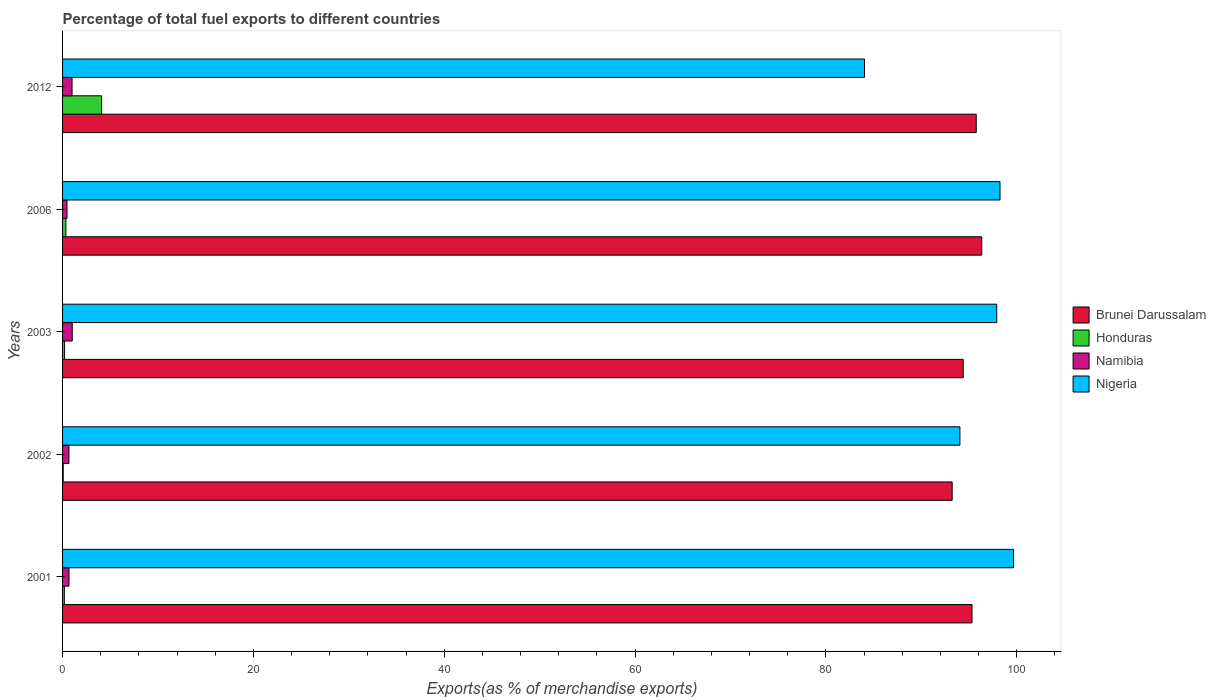How many different coloured bars are there?
Give a very brief answer. 4. How many groups of bars are there?
Your answer should be compact. 5. How many bars are there on the 2nd tick from the bottom?
Your answer should be very brief. 4. What is the label of the 1st group of bars from the top?
Keep it short and to the point. 2012. What is the percentage of exports to different countries in Brunei Darussalam in 2012?
Your answer should be compact. 95.75. Across all years, what is the maximum percentage of exports to different countries in Nigeria?
Ensure brevity in your answer.  99.66. Across all years, what is the minimum percentage of exports to different countries in Brunei Darussalam?
Ensure brevity in your answer.  93.23. In which year was the percentage of exports to different countries in Nigeria maximum?
Ensure brevity in your answer.  2001. In which year was the percentage of exports to different countries in Nigeria minimum?
Your answer should be very brief. 2012. What is the total percentage of exports to different countries in Namibia in the graph?
Make the answer very short. 3.81. What is the difference between the percentage of exports to different countries in Brunei Darussalam in 2001 and that in 2003?
Your answer should be compact. 0.92. What is the difference between the percentage of exports to different countries in Brunei Darussalam in 2006 and the percentage of exports to different countries in Honduras in 2003?
Offer a very short reply. 96.12. What is the average percentage of exports to different countries in Brunei Darussalam per year?
Keep it short and to the point. 95. In the year 2002, what is the difference between the percentage of exports to different countries in Honduras and percentage of exports to different countries in Namibia?
Ensure brevity in your answer.  -0.6. In how many years, is the percentage of exports to different countries in Honduras greater than 80 %?
Provide a short and direct response. 0. What is the ratio of the percentage of exports to different countries in Nigeria in 2002 to that in 2003?
Provide a succinct answer. 0.96. Is the percentage of exports to different countries in Nigeria in 2001 less than that in 2002?
Ensure brevity in your answer.  No. What is the difference between the highest and the second highest percentage of exports to different countries in Namibia?
Keep it short and to the point. 0.02. What is the difference between the highest and the lowest percentage of exports to different countries in Nigeria?
Your answer should be compact. 15.62. Is it the case that in every year, the sum of the percentage of exports to different countries in Nigeria and percentage of exports to different countries in Namibia is greater than the sum of percentage of exports to different countries in Honduras and percentage of exports to different countries in Brunei Darussalam?
Keep it short and to the point. Yes. What does the 2nd bar from the top in 2001 represents?
Your answer should be compact. Namibia. What does the 1st bar from the bottom in 2003 represents?
Offer a terse response. Brunei Darussalam. Is it the case that in every year, the sum of the percentage of exports to different countries in Brunei Darussalam and percentage of exports to different countries in Namibia is greater than the percentage of exports to different countries in Honduras?
Offer a terse response. Yes. What is the difference between two consecutive major ticks on the X-axis?
Your answer should be compact. 20. Does the graph contain any zero values?
Give a very brief answer. No. Does the graph contain grids?
Your response must be concise. No. Where does the legend appear in the graph?
Provide a short and direct response. Center right. How are the legend labels stacked?
Make the answer very short. Vertical. What is the title of the graph?
Provide a short and direct response. Percentage of total fuel exports to different countries. Does "Zambia" appear as one of the legend labels in the graph?
Your answer should be compact. No. What is the label or title of the X-axis?
Give a very brief answer. Exports(as % of merchandise exports). What is the label or title of the Y-axis?
Offer a very short reply. Years. What is the Exports(as % of merchandise exports) of Brunei Darussalam in 2001?
Offer a very short reply. 95.31. What is the Exports(as % of merchandise exports) of Honduras in 2001?
Offer a very short reply. 0.18. What is the Exports(as % of merchandise exports) in Namibia in 2001?
Your answer should be compact. 0.67. What is the Exports(as % of merchandise exports) in Nigeria in 2001?
Your answer should be very brief. 99.66. What is the Exports(as % of merchandise exports) in Brunei Darussalam in 2002?
Keep it short and to the point. 93.23. What is the Exports(as % of merchandise exports) in Honduras in 2002?
Offer a very short reply. 0.07. What is the Exports(as % of merchandise exports) of Namibia in 2002?
Provide a succinct answer. 0.67. What is the Exports(as % of merchandise exports) in Nigeria in 2002?
Make the answer very short. 94.04. What is the Exports(as % of merchandise exports) in Brunei Darussalam in 2003?
Keep it short and to the point. 94.38. What is the Exports(as % of merchandise exports) of Honduras in 2003?
Your answer should be very brief. 0.21. What is the Exports(as % of merchandise exports) in Namibia in 2003?
Provide a succinct answer. 1.01. What is the Exports(as % of merchandise exports) of Nigeria in 2003?
Ensure brevity in your answer.  97.9. What is the Exports(as % of merchandise exports) of Brunei Darussalam in 2006?
Provide a short and direct response. 96.33. What is the Exports(as % of merchandise exports) in Honduras in 2006?
Keep it short and to the point. 0.35. What is the Exports(as % of merchandise exports) of Namibia in 2006?
Make the answer very short. 0.47. What is the Exports(as % of merchandise exports) of Nigeria in 2006?
Your response must be concise. 98.24. What is the Exports(as % of merchandise exports) of Brunei Darussalam in 2012?
Keep it short and to the point. 95.75. What is the Exports(as % of merchandise exports) of Honduras in 2012?
Offer a terse response. 4.09. What is the Exports(as % of merchandise exports) in Namibia in 2012?
Your answer should be compact. 0.99. What is the Exports(as % of merchandise exports) of Nigeria in 2012?
Offer a terse response. 84.04. Across all years, what is the maximum Exports(as % of merchandise exports) of Brunei Darussalam?
Ensure brevity in your answer.  96.33. Across all years, what is the maximum Exports(as % of merchandise exports) of Honduras?
Provide a succinct answer. 4.09. Across all years, what is the maximum Exports(as % of merchandise exports) in Namibia?
Your answer should be very brief. 1.01. Across all years, what is the maximum Exports(as % of merchandise exports) of Nigeria?
Make the answer very short. 99.66. Across all years, what is the minimum Exports(as % of merchandise exports) of Brunei Darussalam?
Your response must be concise. 93.23. Across all years, what is the minimum Exports(as % of merchandise exports) of Honduras?
Your response must be concise. 0.07. Across all years, what is the minimum Exports(as % of merchandise exports) of Namibia?
Provide a succinct answer. 0.47. Across all years, what is the minimum Exports(as % of merchandise exports) in Nigeria?
Provide a succinct answer. 84.04. What is the total Exports(as % of merchandise exports) in Brunei Darussalam in the graph?
Offer a very short reply. 474.99. What is the total Exports(as % of merchandise exports) in Honduras in the graph?
Your answer should be compact. 4.9. What is the total Exports(as % of merchandise exports) in Namibia in the graph?
Offer a very short reply. 3.81. What is the total Exports(as % of merchandise exports) in Nigeria in the graph?
Offer a very short reply. 473.87. What is the difference between the Exports(as % of merchandise exports) in Brunei Darussalam in 2001 and that in 2002?
Ensure brevity in your answer.  2.08. What is the difference between the Exports(as % of merchandise exports) in Honduras in 2001 and that in 2002?
Keep it short and to the point. 0.12. What is the difference between the Exports(as % of merchandise exports) of Namibia in 2001 and that in 2002?
Your answer should be compact. 0.01. What is the difference between the Exports(as % of merchandise exports) of Nigeria in 2001 and that in 2002?
Ensure brevity in your answer.  5.62. What is the difference between the Exports(as % of merchandise exports) in Brunei Darussalam in 2001 and that in 2003?
Provide a short and direct response. 0.92. What is the difference between the Exports(as % of merchandise exports) in Honduras in 2001 and that in 2003?
Keep it short and to the point. -0.03. What is the difference between the Exports(as % of merchandise exports) of Namibia in 2001 and that in 2003?
Your answer should be compact. -0.34. What is the difference between the Exports(as % of merchandise exports) in Nigeria in 2001 and that in 2003?
Give a very brief answer. 1.76. What is the difference between the Exports(as % of merchandise exports) of Brunei Darussalam in 2001 and that in 2006?
Your answer should be very brief. -1.02. What is the difference between the Exports(as % of merchandise exports) of Honduras in 2001 and that in 2006?
Provide a short and direct response. -0.17. What is the difference between the Exports(as % of merchandise exports) of Namibia in 2001 and that in 2006?
Provide a succinct answer. 0.21. What is the difference between the Exports(as % of merchandise exports) of Nigeria in 2001 and that in 2006?
Offer a very short reply. 1.42. What is the difference between the Exports(as % of merchandise exports) of Brunei Darussalam in 2001 and that in 2012?
Your answer should be very brief. -0.44. What is the difference between the Exports(as % of merchandise exports) of Honduras in 2001 and that in 2012?
Give a very brief answer. -3.91. What is the difference between the Exports(as % of merchandise exports) of Namibia in 2001 and that in 2012?
Provide a short and direct response. -0.32. What is the difference between the Exports(as % of merchandise exports) of Nigeria in 2001 and that in 2012?
Offer a very short reply. 15.62. What is the difference between the Exports(as % of merchandise exports) of Brunei Darussalam in 2002 and that in 2003?
Keep it short and to the point. -1.16. What is the difference between the Exports(as % of merchandise exports) of Honduras in 2002 and that in 2003?
Give a very brief answer. -0.14. What is the difference between the Exports(as % of merchandise exports) of Namibia in 2002 and that in 2003?
Provide a short and direct response. -0.35. What is the difference between the Exports(as % of merchandise exports) in Nigeria in 2002 and that in 2003?
Keep it short and to the point. -3.86. What is the difference between the Exports(as % of merchandise exports) in Brunei Darussalam in 2002 and that in 2006?
Give a very brief answer. -3.1. What is the difference between the Exports(as % of merchandise exports) in Honduras in 2002 and that in 2006?
Provide a succinct answer. -0.28. What is the difference between the Exports(as % of merchandise exports) of Namibia in 2002 and that in 2006?
Your response must be concise. 0.2. What is the difference between the Exports(as % of merchandise exports) in Nigeria in 2002 and that in 2006?
Your answer should be compact. -4.2. What is the difference between the Exports(as % of merchandise exports) in Brunei Darussalam in 2002 and that in 2012?
Provide a succinct answer. -2.52. What is the difference between the Exports(as % of merchandise exports) in Honduras in 2002 and that in 2012?
Your answer should be compact. -4.02. What is the difference between the Exports(as % of merchandise exports) in Namibia in 2002 and that in 2012?
Provide a short and direct response. -0.33. What is the difference between the Exports(as % of merchandise exports) of Nigeria in 2002 and that in 2012?
Your answer should be very brief. 10. What is the difference between the Exports(as % of merchandise exports) in Brunei Darussalam in 2003 and that in 2006?
Your answer should be very brief. -1.94. What is the difference between the Exports(as % of merchandise exports) of Honduras in 2003 and that in 2006?
Keep it short and to the point. -0.14. What is the difference between the Exports(as % of merchandise exports) of Namibia in 2003 and that in 2006?
Keep it short and to the point. 0.55. What is the difference between the Exports(as % of merchandise exports) of Nigeria in 2003 and that in 2006?
Offer a very short reply. -0.34. What is the difference between the Exports(as % of merchandise exports) in Brunei Darussalam in 2003 and that in 2012?
Provide a short and direct response. -1.37. What is the difference between the Exports(as % of merchandise exports) of Honduras in 2003 and that in 2012?
Provide a succinct answer. -3.88. What is the difference between the Exports(as % of merchandise exports) in Namibia in 2003 and that in 2012?
Keep it short and to the point. 0.02. What is the difference between the Exports(as % of merchandise exports) in Nigeria in 2003 and that in 2012?
Your response must be concise. 13.86. What is the difference between the Exports(as % of merchandise exports) of Brunei Darussalam in 2006 and that in 2012?
Make the answer very short. 0.58. What is the difference between the Exports(as % of merchandise exports) of Honduras in 2006 and that in 2012?
Make the answer very short. -3.74. What is the difference between the Exports(as % of merchandise exports) in Namibia in 2006 and that in 2012?
Give a very brief answer. -0.53. What is the difference between the Exports(as % of merchandise exports) of Nigeria in 2006 and that in 2012?
Keep it short and to the point. 14.2. What is the difference between the Exports(as % of merchandise exports) of Brunei Darussalam in 2001 and the Exports(as % of merchandise exports) of Honduras in 2002?
Offer a terse response. 95.24. What is the difference between the Exports(as % of merchandise exports) of Brunei Darussalam in 2001 and the Exports(as % of merchandise exports) of Namibia in 2002?
Your answer should be compact. 94.64. What is the difference between the Exports(as % of merchandise exports) in Brunei Darussalam in 2001 and the Exports(as % of merchandise exports) in Nigeria in 2002?
Offer a very short reply. 1.27. What is the difference between the Exports(as % of merchandise exports) of Honduras in 2001 and the Exports(as % of merchandise exports) of Namibia in 2002?
Provide a succinct answer. -0.48. What is the difference between the Exports(as % of merchandise exports) of Honduras in 2001 and the Exports(as % of merchandise exports) of Nigeria in 2002?
Your answer should be compact. -93.85. What is the difference between the Exports(as % of merchandise exports) of Namibia in 2001 and the Exports(as % of merchandise exports) of Nigeria in 2002?
Give a very brief answer. -93.36. What is the difference between the Exports(as % of merchandise exports) in Brunei Darussalam in 2001 and the Exports(as % of merchandise exports) in Honduras in 2003?
Offer a terse response. 95.1. What is the difference between the Exports(as % of merchandise exports) in Brunei Darussalam in 2001 and the Exports(as % of merchandise exports) in Namibia in 2003?
Ensure brevity in your answer.  94.29. What is the difference between the Exports(as % of merchandise exports) in Brunei Darussalam in 2001 and the Exports(as % of merchandise exports) in Nigeria in 2003?
Provide a short and direct response. -2.59. What is the difference between the Exports(as % of merchandise exports) of Honduras in 2001 and the Exports(as % of merchandise exports) of Namibia in 2003?
Ensure brevity in your answer.  -0.83. What is the difference between the Exports(as % of merchandise exports) of Honduras in 2001 and the Exports(as % of merchandise exports) of Nigeria in 2003?
Ensure brevity in your answer.  -97.71. What is the difference between the Exports(as % of merchandise exports) in Namibia in 2001 and the Exports(as % of merchandise exports) in Nigeria in 2003?
Make the answer very short. -97.22. What is the difference between the Exports(as % of merchandise exports) in Brunei Darussalam in 2001 and the Exports(as % of merchandise exports) in Honduras in 2006?
Your response must be concise. 94.96. What is the difference between the Exports(as % of merchandise exports) in Brunei Darussalam in 2001 and the Exports(as % of merchandise exports) in Namibia in 2006?
Your answer should be compact. 94.84. What is the difference between the Exports(as % of merchandise exports) of Brunei Darussalam in 2001 and the Exports(as % of merchandise exports) of Nigeria in 2006?
Your response must be concise. -2.93. What is the difference between the Exports(as % of merchandise exports) in Honduras in 2001 and the Exports(as % of merchandise exports) in Namibia in 2006?
Your response must be concise. -0.28. What is the difference between the Exports(as % of merchandise exports) of Honduras in 2001 and the Exports(as % of merchandise exports) of Nigeria in 2006?
Your answer should be compact. -98.05. What is the difference between the Exports(as % of merchandise exports) in Namibia in 2001 and the Exports(as % of merchandise exports) in Nigeria in 2006?
Provide a succinct answer. -97.56. What is the difference between the Exports(as % of merchandise exports) of Brunei Darussalam in 2001 and the Exports(as % of merchandise exports) of Honduras in 2012?
Provide a short and direct response. 91.22. What is the difference between the Exports(as % of merchandise exports) of Brunei Darussalam in 2001 and the Exports(as % of merchandise exports) of Namibia in 2012?
Offer a very short reply. 94.31. What is the difference between the Exports(as % of merchandise exports) of Brunei Darussalam in 2001 and the Exports(as % of merchandise exports) of Nigeria in 2012?
Ensure brevity in your answer.  11.27. What is the difference between the Exports(as % of merchandise exports) in Honduras in 2001 and the Exports(as % of merchandise exports) in Namibia in 2012?
Your response must be concise. -0.81. What is the difference between the Exports(as % of merchandise exports) in Honduras in 2001 and the Exports(as % of merchandise exports) in Nigeria in 2012?
Your answer should be compact. -83.85. What is the difference between the Exports(as % of merchandise exports) in Namibia in 2001 and the Exports(as % of merchandise exports) in Nigeria in 2012?
Provide a short and direct response. -83.36. What is the difference between the Exports(as % of merchandise exports) of Brunei Darussalam in 2002 and the Exports(as % of merchandise exports) of Honduras in 2003?
Your answer should be compact. 93.02. What is the difference between the Exports(as % of merchandise exports) in Brunei Darussalam in 2002 and the Exports(as % of merchandise exports) in Namibia in 2003?
Ensure brevity in your answer.  92.21. What is the difference between the Exports(as % of merchandise exports) of Brunei Darussalam in 2002 and the Exports(as % of merchandise exports) of Nigeria in 2003?
Offer a terse response. -4.67. What is the difference between the Exports(as % of merchandise exports) of Honduras in 2002 and the Exports(as % of merchandise exports) of Namibia in 2003?
Ensure brevity in your answer.  -0.95. What is the difference between the Exports(as % of merchandise exports) of Honduras in 2002 and the Exports(as % of merchandise exports) of Nigeria in 2003?
Offer a very short reply. -97.83. What is the difference between the Exports(as % of merchandise exports) of Namibia in 2002 and the Exports(as % of merchandise exports) of Nigeria in 2003?
Ensure brevity in your answer.  -97.23. What is the difference between the Exports(as % of merchandise exports) in Brunei Darussalam in 2002 and the Exports(as % of merchandise exports) in Honduras in 2006?
Your answer should be very brief. 92.88. What is the difference between the Exports(as % of merchandise exports) in Brunei Darussalam in 2002 and the Exports(as % of merchandise exports) in Namibia in 2006?
Offer a terse response. 92.76. What is the difference between the Exports(as % of merchandise exports) of Brunei Darussalam in 2002 and the Exports(as % of merchandise exports) of Nigeria in 2006?
Provide a short and direct response. -5.01. What is the difference between the Exports(as % of merchandise exports) in Honduras in 2002 and the Exports(as % of merchandise exports) in Namibia in 2006?
Your answer should be very brief. -0.4. What is the difference between the Exports(as % of merchandise exports) of Honduras in 2002 and the Exports(as % of merchandise exports) of Nigeria in 2006?
Your response must be concise. -98.17. What is the difference between the Exports(as % of merchandise exports) in Namibia in 2002 and the Exports(as % of merchandise exports) in Nigeria in 2006?
Make the answer very short. -97.57. What is the difference between the Exports(as % of merchandise exports) of Brunei Darussalam in 2002 and the Exports(as % of merchandise exports) of Honduras in 2012?
Your response must be concise. 89.14. What is the difference between the Exports(as % of merchandise exports) in Brunei Darussalam in 2002 and the Exports(as % of merchandise exports) in Namibia in 2012?
Give a very brief answer. 92.23. What is the difference between the Exports(as % of merchandise exports) in Brunei Darussalam in 2002 and the Exports(as % of merchandise exports) in Nigeria in 2012?
Give a very brief answer. 9.19. What is the difference between the Exports(as % of merchandise exports) in Honduras in 2002 and the Exports(as % of merchandise exports) in Namibia in 2012?
Offer a terse response. -0.93. What is the difference between the Exports(as % of merchandise exports) of Honduras in 2002 and the Exports(as % of merchandise exports) of Nigeria in 2012?
Keep it short and to the point. -83.97. What is the difference between the Exports(as % of merchandise exports) in Namibia in 2002 and the Exports(as % of merchandise exports) in Nigeria in 2012?
Offer a very short reply. -83.37. What is the difference between the Exports(as % of merchandise exports) of Brunei Darussalam in 2003 and the Exports(as % of merchandise exports) of Honduras in 2006?
Your response must be concise. 94.03. What is the difference between the Exports(as % of merchandise exports) of Brunei Darussalam in 2003 and the Exports(as % of merchandise exports) of Namibia in 2006?
Your answer should be compact. 93.92. What is the difference between the Exports(as % of merchandise exports) in Brunei Darussalam in 2003 and the Exports(as % of merchandise exports) in Nigeria in 2006?
Keep it short and to the point. -3.86. What is the difference between the Exports(as % of merchandise exports) of Honduras in 2003 and the Exports(as % of merchandise exports) of Namibia in 2006?
Offer a very short reply. -0.26. What is the difference between the Exports(as % of merchandise exports) of Honduras in 2003 and the Exports(as % of merchandise exports) of Nigeria in 2006?
Make the answer very short. -98.03. What is the difference between the Exports(as % of merchandise exports) of Namibia in 2003 and the Exports(as % of merchandise exports) of Nigeria in 2006?
Make the answer very short. -97.23. What is the difference between the Exports(as % of merchandise exports) in Brunei Darussalam in 2003 and the Exports(as % of merchandise exports) in Honduras in 2012?
Your answer should be very brief. 90.29. What is the difference between the Exports(as % of merchandise exports) in Brunei Darussalam in 2003 and the Exports(as % of merchandise exports) in Namibia in 2012?
Keep it short and to the point. 93.39. What is the difference between the Exports(as % of merchandise exports) of Brunei Darussalam in 2003 and the Exports(as % of merchandise exports) of Nigeria in 2012?
Provide a short and direct response. 10.34. What is the difference between the Exports(as % of merchandise exports) of Honduras in 2003 and the Exports(as % of merchandise exports) of Namibia in 2012?
Make the answer very short. -0.78. What is the difference between the Exports(as % of merchandise exports) of Honduras in 2003 and the Exports(as % of merchandise exports) of Nigeria in 2012?
Provide a short and direct response. -83.83. What is the difference between the Exports(as % of merchandise exports) in Namibia in 2003 and the Exports(as % of merchandise exports) in Nigeria in 2012?
Your response must be concise. -83.03. What is the difference between the Exports(as % of merchandise exports) in Brunei Darussalam in 2006 and the Exports(as % of merchandise exports) in Honduras in 2012?
Your response must be concise. 92.24. What is the difference between the Exports(as % of merchandise exports) of Brunei Darussalam in 2006 and the Exports(as % of merchandise exports) of Namibia in 2012?
Ensure brevity in your answer.  95.33. What is the difference between the Exports(as % of merchandise exports) in Brunei Darussalam in 2006 and the Exports(as % of merchandise exports) in Nigeria in 2012?
Offer a terse response. 12.29. What is the difference between the Exports(as % of merchandise exports) in Honduras in 2006 and the Exports(as % of merchandise exports) in Namibia in 2012?
Make the answer very short. -0.64. What is the difference between the Exports(as % of merchandise exports) in Honduras in 2006 and the Exports(as % of merchandise exports) in Nigeria in 2012?
Ensure brevity in your answer.  -83.69. What is the difference between the Exports(as % of merchandise exports) of Namibia in 2006 and the Exports(as % of merchandise exports) of Nigeria in 2012?
Give a very brief answer. -83.57. What is the average Exports(as % of merchandise exports) of Brunei Darussalam per year?
Offer a very short reply. 95. What is the average Exports(as % of merchandise exports) of Honduras per year?
Offer a very short reply. 0.98. What is the average Exports(as % of merchandise exports) in Namibia per year?
Provide a short and direct response. 0.76. What is the average Exports(as % of merchandise exports) in Nigeria per year?
Offer a very short reply. 94.77. In the year 2001, what is the difference between the Exports(as % of merchandise exports) of Brunei Darussalam and Exports(as % of merchandise exports) of Honduras?
Keep it short and to the point. 95.12. In the year 2001, what is the difference between the Exports(as % of merchandise exports) of Brunei Darussalam and Exports(as % of merchandise exports) of Namibia?
Offer a terse response. 94.63. In the year 2001, what is the difference between the Exports(as % of merchandise exports) in Brunei Darussalam and Exports(as % of merchandise exports) in Nigeria?
Offer a very short reply. -4.35. In the year 2001, what is the difference between the Exports(as % of merchandise exports) in Honduras and Exports(as % of merchandise exports) in Namibia?
Offer a terse response. -0.49. In the year 2001, what is the difference between the Exports(as % of merchandise exports) in Honduras and Exports(as % of merchandise exports) in Nigeria?
Your answer should be compact. -99.47. In the year 2001, what is the difference between the Exports(as % of merchandise exports) in Namibia and Exports(as % of merchandise exports) in Nigeria?
Offer a terse response. -98.98. In the year 2002, what is the difference between the Exports(as % of merchandise exports) of Brunei Darussalam and Exports(as % of merchandise exports) of Honduras?
Provide a succinct answer. 93.16. In the year 2002, what is the difference between the Exports(as % of merchandise exports) in Brunei Darussalam and Exports(as % of merchandise exports) in Namibia?
Make the answer very short. 92.56. In the year 2002, what is the difference between the Exports(as % of merchandise exports) in Brunei Darussalam and Exports(as % of merchandise exports) in Nigeria?
Your response must be concise. -0.81. In the year 2002, what is the difference between the Exports(as % of merchandise exports) of Honduras and Exports(as % of merchandise exports) of Namibia?
Give a very brief answer. -0.6. In the year 2002, what is the difference between the Exports(as % of merchandise exports) in Honduras and Exports(as % of merchandise exports) in Nigeria?
Offer a terse response. -93.97. In the year 2002, what is the difference between the Exports(as % of merchandise exports) in Namibia and Exports(as % of merchandise exports) in Nigeria?
Provide a short and direct response. -93.37. In the year 2003, what is the difference between the Exports(as % of merchandise exports) in Brunei Darussalam and Exports(as % of merchandise exports) in Honduras?
Give a very brief answer. 94.17. In the year 2003, what is the difference between the Exports(as % of merchandise exports) of Brunei Darussalam and Exports(as % of merchandise exports) of Namibia?
Your response must be concise. 93.37. In the year 2003, what is the difference between the Exports(as % of merchandise exports) in Brunei Darussalam and Exports(as % of merchandise exports) in Nigeria?
Keep it short and to the point. -3.52. In the year 2003, what is the difference between the Exports(as % of merchandise exports) of Honduras and Exports(as % of merchandise exports) of Namibia?
Ensure brevity in your answer.  -0.8. In the year 2003, what is the difference between the Exports(as % of merchandise exports) in Honduras and Exports(as % of merchandise exports) in Nigeria?
Give a very brief answer. -97.69. In the year 2003, what is the difference between the Exports(as % of merchandise exports) of Namibia and Exports(as % of merchandise exports) of Nigeria?
Ensure brevity in your answer.  -96.88. In the year 2006, what is the difference between the Exports(as % of merchandise exports) of Brunei Darussalam and Exports(as % of merchandise exports) of Honduras?
Ensure brevity in your answer.  95.98. In the year 2006, what is the difference between the Exports(as % of merchandise exports) of Brunei Darussalam and Exports(as % of merchandise exports) of Namibia?
Offer a terse response. 95.86. In the year 2006, what is the difference between the Exports(as % of merchandise exports) in Brunei Darussalam and Exports(as % of merchandise exports) in Nigeria?
Your answer should be very brief. -1.91. In the year 2006, what is the difference between the Exports(as % of merchandise exports) of Honduras and Exports(as % of merchandise exports) of Namibia?
Keep it short and to the point. -0.11. In the year 2006, what is the difference between the Exports(as % of merchandise exports) of Honduras and Exports(as % of merchandise exports) of Nigeria?
Your response must be concise. -97.89. In the year 2006, what is the difference between the Exports(as % of merchandise exports) in Namibia and Exports(as % of merchandise exports) in Nigeria?
Give a very brief answer. -97.77. In the year 2012, what is the difference between the Exports(as % of merchandise exports) of Brunei Darussalam and Exports(as % of merchandise exports) of Honduras?
Offer a terse response. 91.66. In the year 2012, what is the difference between the Exports(as % of merchandise exports) of Brunei Darussalam and Exports(as % of merchandise exports) of Namibia?
Your answer should be very brief. 94.76. In the year 2012, what is the difference between the Exports(as % of merchandise exports) in Brunei Darussalam and Exports(as % of merchandise exports) in Nigeria?
Keep it short and to the point. 11.71. In the year 2012, what is the difference between the Exports(as % of merchandise exports) in Honduras and Exports(as % of merchandise exports) in Namibia?
Make the answer very short. 3.1. In the year 2012, what is the difference between the Exports(as % of merchandise exports) in Honduras and Exports(as % of merchandise exports) in Nigeria?
Ensure brevity in your answer.  -79.95. In the year 2012, what is the difference between the Exports(as % of merchandise exports) of Namibia and Exports(as % of merchandise exports) of Nigeria?
Your response must be concise. -83.05. What is the ratio of the Exports(as % of merchandise exports) of Brunei Darussalam in 2001 to that in 2002?
Make the answer very short. 1.02. What is the ratio of the Exports(as % of merchandise exports) of Honduras in 2001 to that in 2002?
Offer a terse response. 2.77. What is the ratio of the Exports(as % of merchandise exports) of Namibia in 2001 to that in 2002?
Offer a very short reply. 1.01. What is the ratio of the Exports(as % of merchandise exports) in Nigeria in 2001 to that in 2002?
Your answer should be compact. 1.06. What is the ratio of the Exports(as % of merchandise exports) of Brunei Darussalam in 2001 to that in 2003?
Keep it short and to the point. 1.01. What is the ratio of the Exports(as % of merchandise exports) in Honduras in 2001 to that in 2003?
Offer a very short reply. 0.88. What is the ratio of the Exports(as % of merchandise exports) in Namibia in 2001 to that in 2003?
Offer a terse response. 0.67. What is the ratio of the Exports(as % of merchandise exports) in Nigeria in 2001 to that in 2003?
Provide a short and direct response. 1.02. What is the ratio of the Exports(as % of merchandise exports) of Brunei Darussalam in 2001 to that in 2006?
Ensure brevity in your answer.  0.99. What is the ratio of the Exports(as % of merchandise exports) of Honduras in 2001 to that in 2006?
Offer a terse response. 0.53. What is the ratio of the Exports(as % of merchandise exports) in Namibia in 2001 to that in 2006?
Your answer should be compact. 1.45. What is the ratio of the Exports(as % of merchandise exports) in Nigeria in 2001 to that in 2006?
Provide a succinct answer. 1.01. What is the ratio of the Exports(as % of merchandise exports) of Brunei Darussalam in 2001 to that in 2012?
Offer a terse response. 1. What is the ratio of the Exports(as % of merchandise exports) of Honduras in 2001 to that in 2012?
Give a very brief answer. 0.05. What is the ratio of the Exports(as % of merchandise exports) of Namibia in 2001 to that in 2012?
Give a very brief answer. 0.68. What is the ratio of the Exports(as % of merchandise exports) in Nigeria in 2001 to that in 2012?
Your response must be concise. 1.19. What is the ratio of the Exports(as % of merchandise exports) in Brunei Darussalam in 2002 to that in 2003?
Offer a very short reply. 0.99. What is the ratio of the Exports(as % of merchandise exports) in Honduras in 2002 to that in 2003?
Provide a short and direct response. 0.32. What is the ratio of the Exports(as % of merchandise exports) of Namibia in 2002 to that in 2003?
Provide a short and direct response. 0.66. What is the ratio of the Exports(as % of merchandise exports) of Nigeria in 2002 to that in 2003?
Keep it short and to the point. 0.96. What is the ratio of the Exports(as % of merchandise exports) in Brunei Darussalam in 2002 to that in 2006?
Keep it short and to the point. 0.97. What is the ratio of the Exports(as % of merchandise exports) of Honduras in 2002 to that in 2006?
Provide a succinct answer. 0.19. What is the ratio of the Exports(as % of merchandise exports) in Namibia in 2002 to that in 2006?
Your response must be concise. 1.43. What is the ratio of the Exports(as % of merchandise exports) of Nigeria in 2002 to that in 2006?
Offer a terse response. 0.96. What is the ratio of the Exports(as % of merchandise exports) in Brunei Darussalam in 2002 to that in 2012?
Offer a very short reply. 0.97. What is the ratio of the Exports(as % of merchandise exports) in Honduras in 2002 to that in 2012?
Your answer should be very brief. 0.02. What is the ratio of the Exports(as % of merchandise exports) of Namibia in 2002 to that in 2012?
Offer a very short reply. 0.67. What is the ratio of the Exports(as % of merchandise exports) in Nigeria in 2002 to that in 2012?
Keep it short and to the point. 1.12. What is the ratio of the Exports(as % of merchandise exports) of Brunei Darussalam in 2003 to that in 2006?
Give a very brief answer. 0.98. What is the ratio of the Exports(as % of merchandise exports) of Honduras in 2003 to that in 2006?
Provide a succinct answer. 0.6. What is the ratio of the Exports(as % of merchandise exports) in Namibia in 2003 to that in 2006?
Give a very brief answer. 2.18. What is the ratio of the Exports(as % of merchandise exports) of Nigeria in 2003 to that in 2006?
Offer a very short reply. 1. What is the ratio of the Exports(as % of merchandise exports) of Brunei Darussalam in 2003 to that in 2012?
Give a very brief answer. 0.99. What is the ratio of the Exports(as % of merchandise exports) in Honduras in 2003 to that in 2012?
Make the answer very short. 0.05. What is the ratio of the Exports(as % of merchandise exports) in Namibia in 2003 to that in 2012?
Provide a succinct answer. 1.02. What is the ratio of the Exports(as % of merchandise exports) in Nigeria in 2003 to that in 2012?
Provide a short and direct response. 1.16. What is the ratio of the Exports(as % of merchandise exports) in Honduras in 2006 to that in 2012?
Provide a succinct answer. 0.09. What is the ratio of the Exports(as % of merchandise exports) of Namibia in 2006 to that in 2012?
Give a very brief answer. 0.47. What is the ratio of the Exports(as % of merchandise exports) of Nigeria in 2006 to that in 2012?
Give a very brief answer. 1.17. What is the difference between the highest and the second highest Exports(as % of merchandise exports) in Brunei Darussalam?
Offer a terse response. 0.58. What is the difference between the highest and the second highest Exports(as % of merchandise exports) in Honduras?
Give a very brief answer. 3.74. What is the difference between the highest and the second highest Exports(as % of merchandise exports) of Namibia?
Your response must be concise. 0.02. What is the difference between the highest and the second highest Exports(as % of merchandise exports) of Nigeria?
Offer a very short reply. 1.42. What is the difference between the highest and the lowest Exports(as % of merchandise exports) of Brunei Darussalam?
Your answer should be compact. 3.1. What is the difference between the highest and the lowest Exports(as % of merchandise exports) of Honduras?
Provide a succinct answer. 4.02. What is the difference between the highest and the lowest Exports(as % of merchandise exports) in Namibia?
Provide a succinct answer. 0.55. What is the difference between the highest and the lowest Exports(as % of merchandise exports) of Nigeria?
Keep it short and to the point. 15.62. 